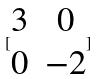Convert formula to latex. <formula><loc_0><loc_0><loc_500><loc_500>[ \begin{matrix} 3 & 0 \\ 0 & - 2 \end{matrix} ]</formula> 